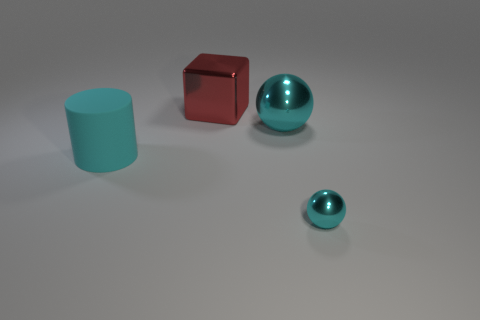Add 1 purple cubes. How many objects exist? 5 Subtract all cylinders. How many objects are left? 3 Subtract 0 purple cylinders. How many objects are left? 4 Subtract all tiny cyan metallic spheres. Subtract all metal blocks. How many objects are left? 2 Add 1 cyan balls. How many cyan balls are left? 3 Add 4 big metallic spheres. How many big metallic spheres exist? 5 